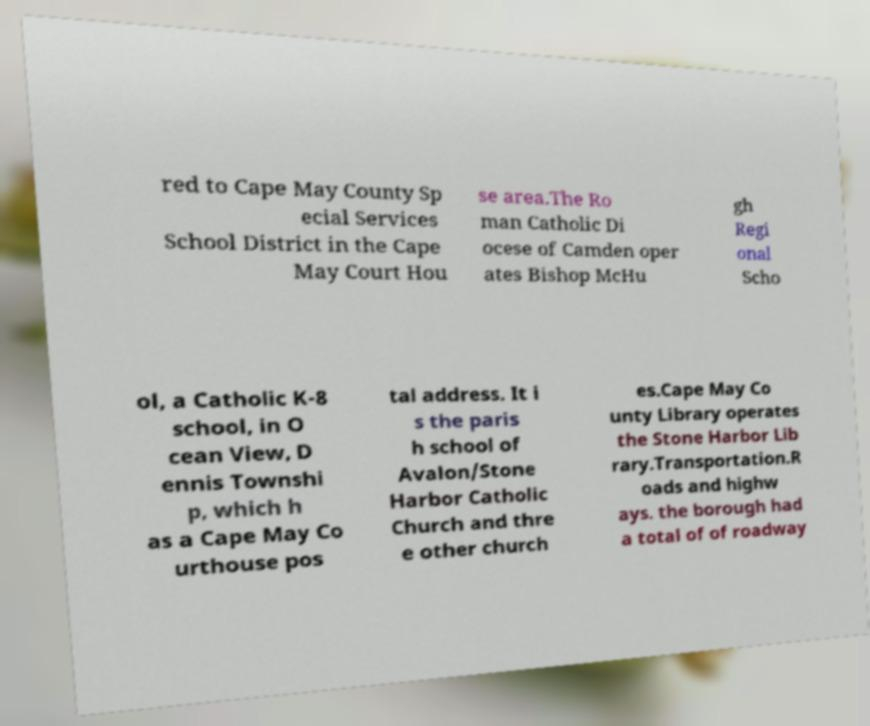Can you accurately transcribe the text from the provided image for me? red to Cape May County Sp ecial Services School District in the Cape May Court Hou se area.The Ro man Catholic Di ocese of Camden oper ates Bishop McHu gh Regi onal Scho ol, a Catholic K-8 school, in O cean View, D ennis Townshi p, which h as a Cape May Co urthouse pos tal address. It i s the paris h school of Avalon/Stone Harbor Catholic Church and thre e other church es.Cape May Co unty Library operates the Stone Harbor Lib rary.Transportation.R oads and highw ays. the borough had a total of of roadway 